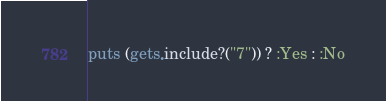<code> <loc_0><loc_0><loc_500><loc_500><_Ruby_>puts (gets.include?("7")) ? :Yes : :No
</code> 